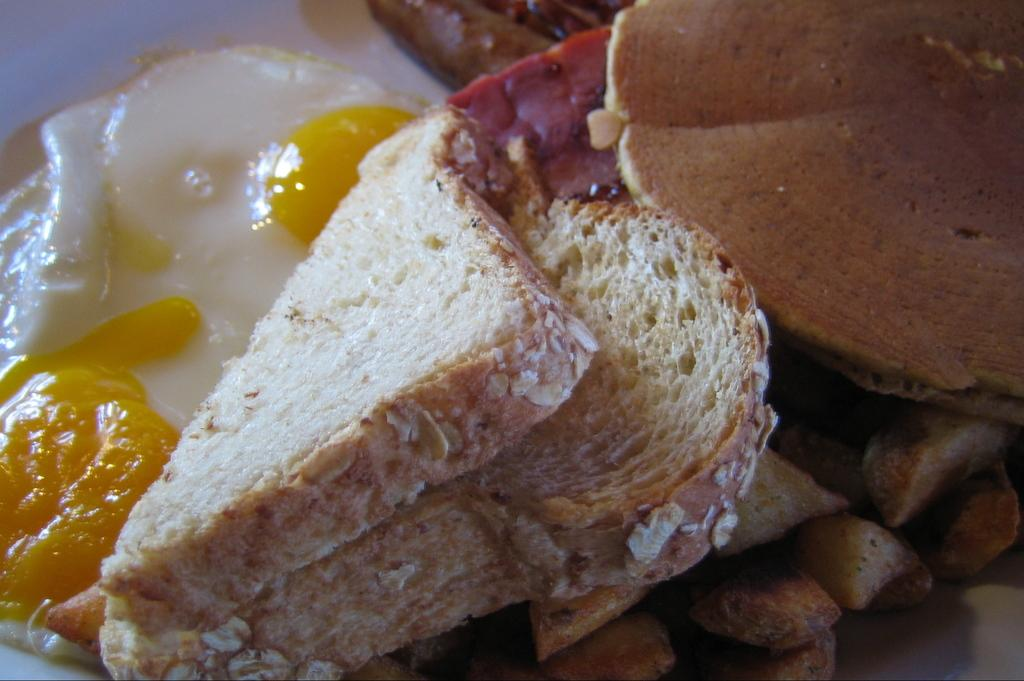What is the focus of the image? The image is a zoomed-in view. What can be seen in the foreground of the image? There are half-boiled eggs in the foreground. What type of food is visible in the image? There is bread visible in the image. Are there any other food items present in the image? Yes, there are other food items present in the image. What day of the week is it in the image? The day of the week cannot be determined from the image, as it does not contain any information about time or date. 